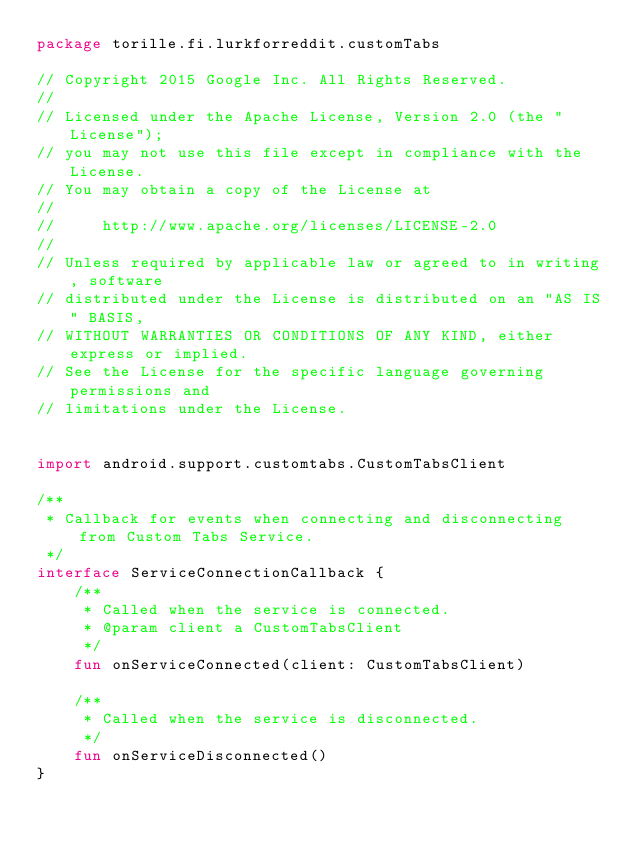<code> <loc_0><loc_0><loc_500><loc_500><_Kotlin_>package torille.fi.lurkforreddit.customTabs

// Copyright 2015 Google Inc. All Rights Reserved.
//
// Licensed under the Apache License, Version 2.0 (the "License");
// you may not use this file except in compliance with the License.
// You may obtain a copy of the License at
//
//     http://www.apache.org/licenses/LICENSE-2.0
//
// Unless required by applicable law or agreed to in writing, software
// distributed under the License is distributed on an "AS IS" BASIS,
// WITHOUT WARRANTIES OR CONDITIONS OF ANY KIND, either express or implied.
// See the License for the specific language governing permissions and
// limitations under the License.


import android.support.customtabs.CustomTabsClient

/**
 * Callback for events when connecting and disconnecting from Custom Tabs Service.
 */
interface ServiceConnectionCallback {
    /**
     * Called when the service is connected.
     * @param client a CustomTabsClient
     */
    fun onServiceConnected(client: CustomTabsClient)

    /**
     * Called when the service is disconnected.
     */
    fun onServiceDisconnected()
}</code> 